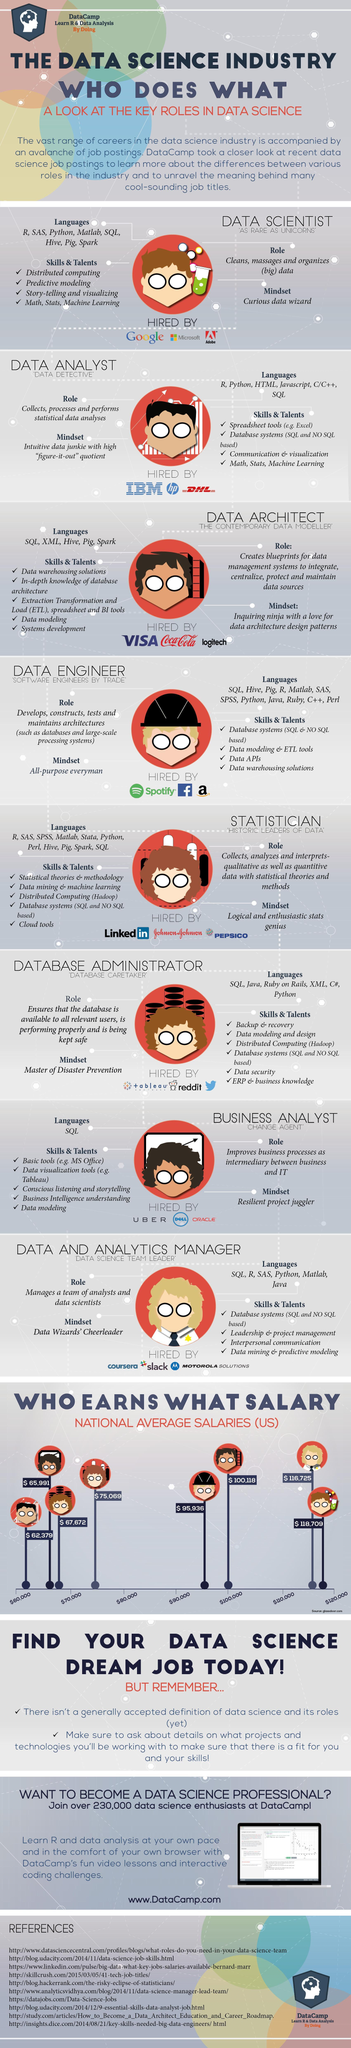Which companies hired for a data scientist role in the U.S.?
Answer the question with a short phrase. Google, Microsoft, Adobe What is the national average salary for business analyst role in the U.S. data science industry? $ 65,991 Which language skill is required for the role of a business analyst? SQL What is the national average salary for database administrator role in the U.S. data science industry? $ 67,672 What is the role of a data & analytics manager in a company? Manages a team of analysts and data scientists Which job in the data science industry of the U.S. has the lowest average salary? DATA ANALYST What should be the mindset of a business analyst in the data science industry? Resilient project juggler Which companies hired for a data analyst role in the U.S.? IBM, hp, DHL Which job in the data science industry of the U.S. has the highest average salary? DATA SCIENTIST 